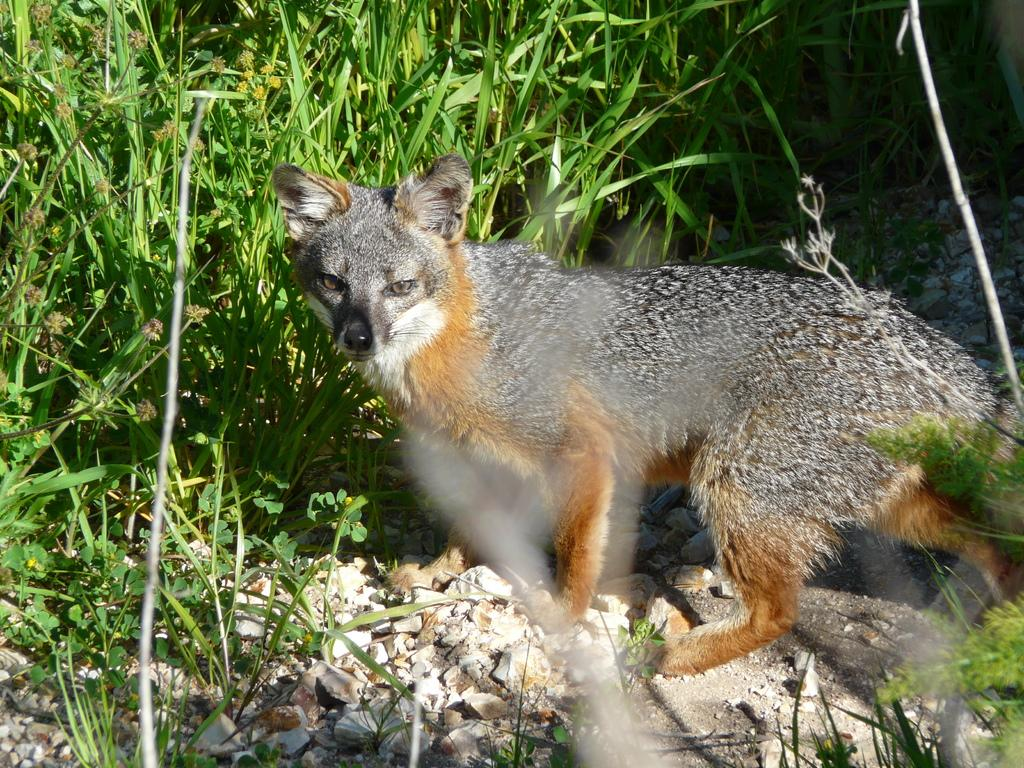What type of natural elements can be seen in the image? There are stones, plants, and grass in the image. What other living organism is present in the image? There is an animal in the image. What type of twist can be seen in the image? There is no twist present in the image. Can you tell me how the mom is interacting with the animal in the image? There is no mention of a mom or any interaction with the animal in the image. 